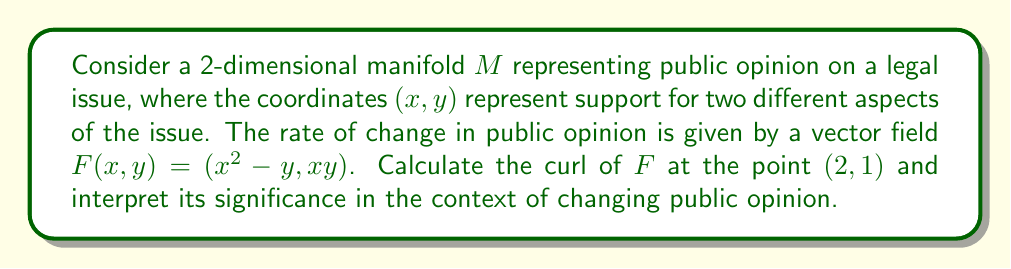Teach me how to tackle this problem. To solve this problem, we'll follow these steps:

1) The curl of a vector field $F(x, y) = (P, Q)$ in 2D is defined as:

   $$\text{curl } F = \frac{\partial Q}{\partial x} - \frac{\partial P}{\partial y}$$

2) In our case, $P = x^2 - y$ and $Q = xy$. Let's calculate the partial derivatives:

   $$\frac{\partial Q}{\partial x} = \frac{\partial}{\partial x}(xy) = y$$

   $$\frac{\partial P}{\partial y} = \frac{\partial}{\partial y}(x^2 - y) = -1$$

3) Now, we can calculate the curl:

   $$\text{curl } F = \frac{\partial Q}{\partial x} - \frac{\partial P}{\partial y} = y - (-1) = y + 1$$

4) At the point $(2, 1)$, we evaluate:

   $$\text{curl } F(2, 1) = 1 + 1 = 2$$

5) Interpretation: In the context of public opinion, a non-zero curl indicates the presence of circular or rotational tendencies in opinion change. The positive value (2) suggests a counterclockwise rotation in the opinion space at the point (2, 1). This could represent a shift in public opinion where support for one aspect of the issue is increasing while support for the other is decreasing, creating a cyclical pattern of opinion change.
Answer: 2 